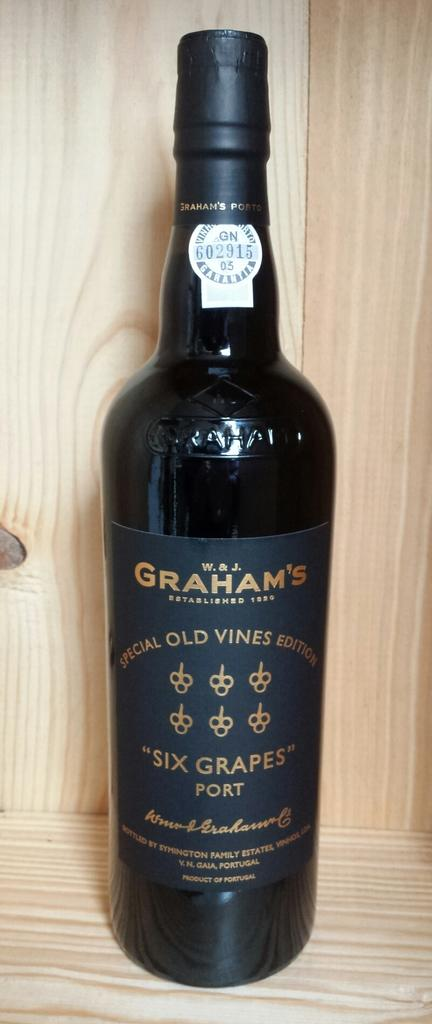Provide a one-sentence caption for the provided image. A bottle of six grapes port sits on a wooden shelf. 